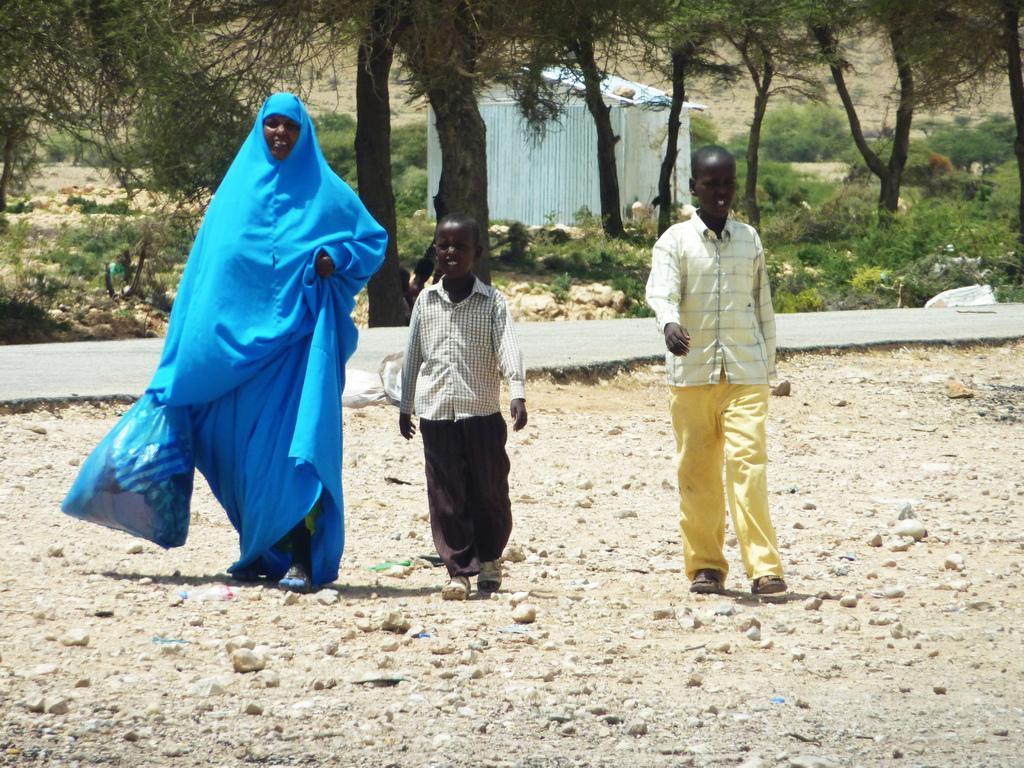Could you give a brief overview of what you see in this image? In this picture we can see three people on the ground and one woman is holding a plastic bag and in the background we can see the road, shed, trees and plants. 